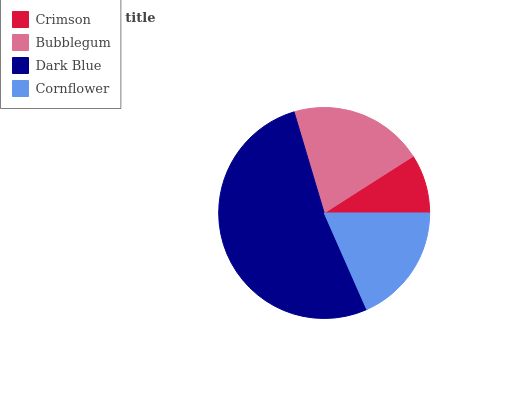Is Crimson the minimum?
Answer yes or no. Yes. Is Dark Blue the maximum?
Answer yes or no. Yes. Is Bubblegum the minimum?
Answer yes or no. No. Is Bubblegum the maximum?
Answer yes or no. No. Is Bubblegum greater than Crimson?
Answer yes or no. Yes. Is Crimson less than Bubblegum?
Answer yes or no. Yes. Is Crimson greater than Bubblegum?
Answer yes or no. No. Is Bubblegum less than Crimson?
Answer yes or no. No. Is Bubblegum the high median?
Answer yes or no. Yes. Is Cornflower the low median?
Answer yes or no. Yes. Is Cornflower the high median?
Answer yes or no. No. Is Bubblegum the low median?
Answer yes or no. No. 